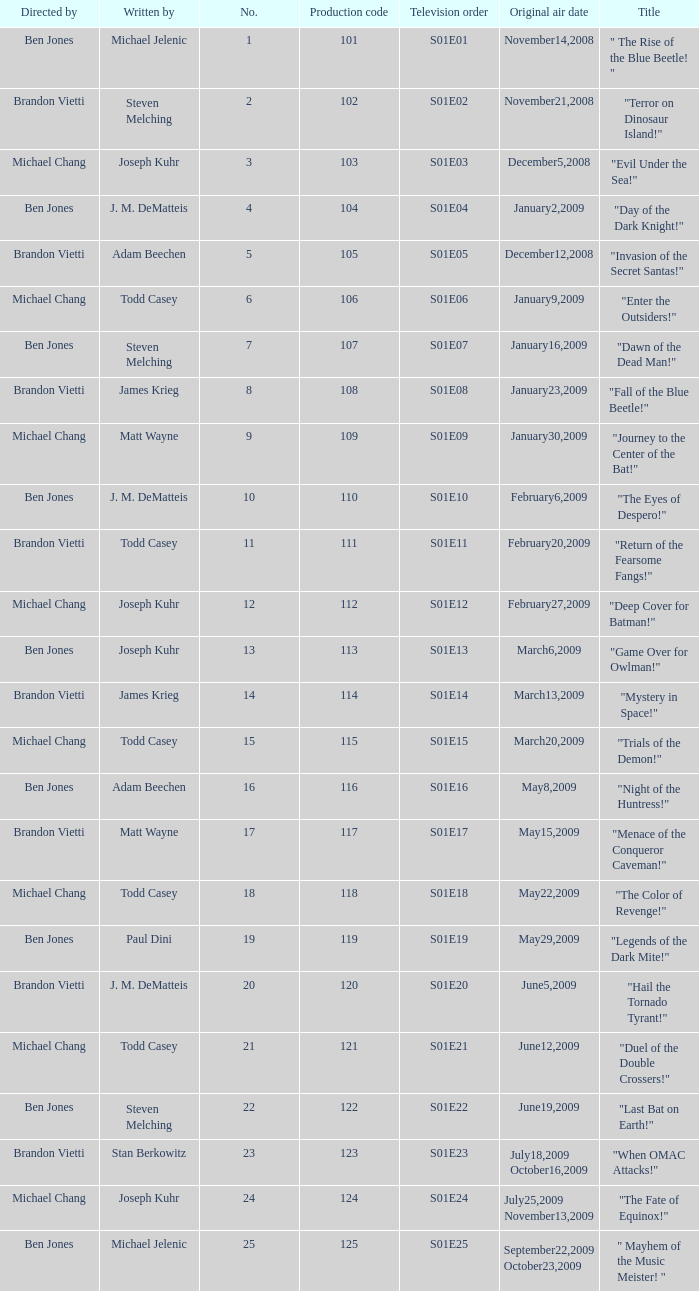What is the the television order of "deep cover for batman!" S01E12. 